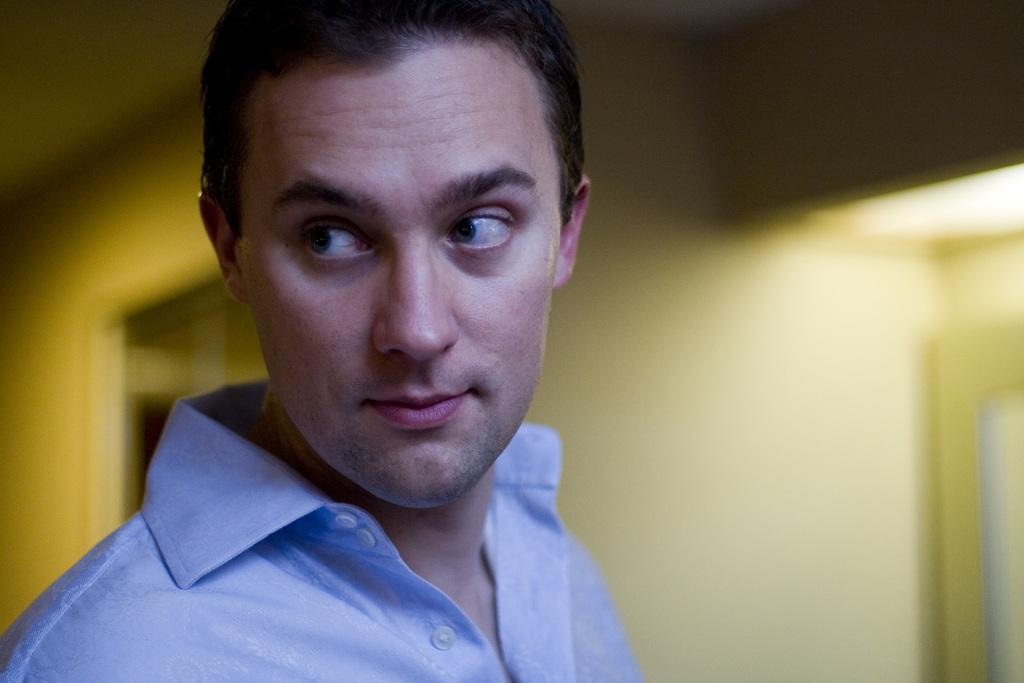Who is present in the image? There is a man in the picture. What is the man wearing? The man is wearing a blue shirt. What type of location is depicted in the image? The image provides an inner view of a house. What type of team is the man supporting in the image? There is no indication of a team or any sports-related activity in the image. 